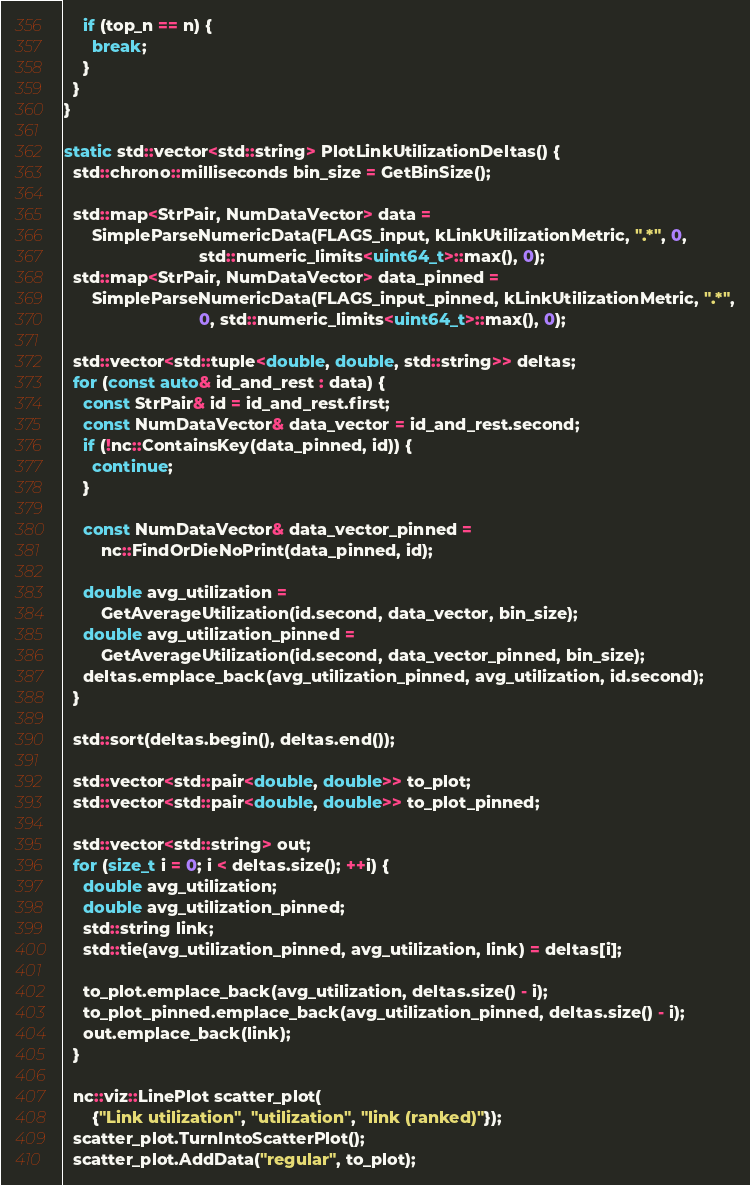Convert code to text. <code><loc_0><loc_0><loc_500><loc_500><_C++_>    if (top_n == n) {
      break;
    }
  }
}

static std::vector<std::string> PlotLinkUtilizationDeltas() {
  std::chrono::milliseconds bin_size = GetBinSize();

  std::map<StrPair, NumDataVector> data =
      SimpleParseNumericData(FLAGS_input, kLinkUtilizationMetric, ".*", 0,
                             std::numeric_limits<uint64_t>::max(), 0);
  std::map<StrPair, NumDataVector> data_pinned =
      SimpleParseNumericData(FLAGS_input_pinned, kLinkUtilizationMetric, ".*",
                             0, std::numeric_limits<uint64_t>::max(), 0);

  std::vector<std::tuple<double, double, std::string>> deltas;
  for (const auto& id_and_rest : data) {
    const StrPair& id = id_and_rest.first;
    const NumDataVector& data_vector = id_and_rest.second;
    if (!nc::ContainsKey(data_pinned, id)) {
      continue;
    }

    const NumDataVector& data_vector_pinned =
        nc::FindOrDieNoPrint(data_pinned, id);

    double avg_utilization =
        GetAverageUtilization(id.second, data_vector, bin_size);
    double avg_utilization_pinned =
        GetAverageUtilization(id.second, data_vector_pinned, bin_size);
    deltas.emplace_back(avg_utilization_pinned, avg_utilization, id.second);
  }

  std::sort(deltas.begin(), deltas.end());

  std::vector<std::pair<double, double>> to_plot;
  std::vector<std::pair<double, double>> to_plot_pinned;

  std::vector<std::string> out;
  for (size_t i = 0; i < deltas.size(); ++i) {
    double avg_utilization;
    double avg_utilization_pinned;
    std::string link;
    std::tie(avg_utilization_pinned, avg_utilization, link) = deltas[i];

    to_plot.emplace_back(avg_utilization, deltas.size() - i);
    to_plot_pinned.emplace_back(avg_utilization_pinned, deltas.size() - i);
    out.emplace_back(link);
  }

  nc::viz::LinePlot scatter_plot(
      {"Link utilization", "utilization", "link (ranked)"});
  scatter_plot.TurnIntoScatterPlot();
  scatter_plot.AddData("regular", to_plot);</code> 